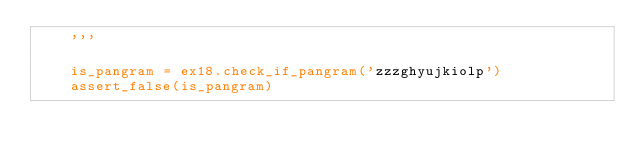<code> <loc_0><loc_0><loc_500><loc_500><_Python_>    '''

    is_pangram = ex18.check_if_pangram('zzzghyujkiolp')
    assert_false(is_pangram)
</code> 